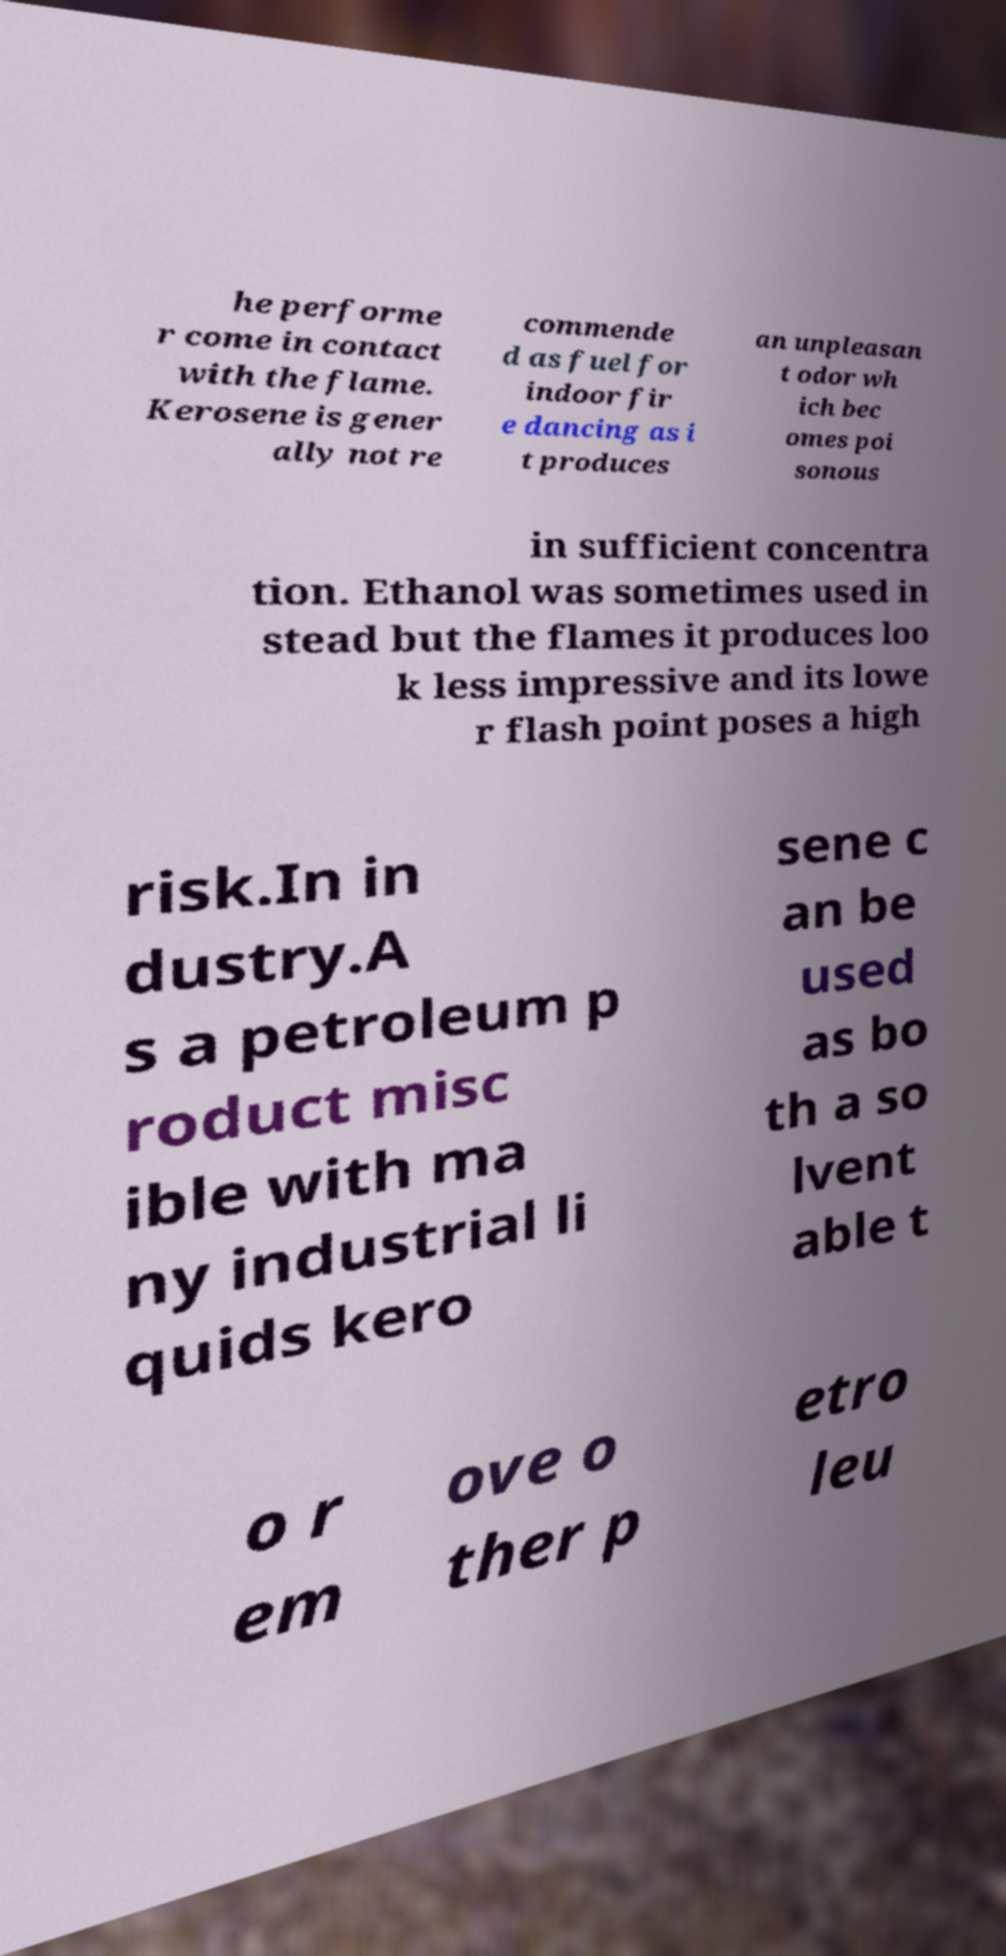Could you extract and type out the text from this image? he performe r come in contact with the flame. Kerosene is gener ally not re commende d as fuel for indoor fir e dancing as i t produces an unpleasan t odor wh ich bec omes poi sonous in sufficient concentra tion. Ethanol was sometimes used in stead but the flames it produces loo k less impressive and its lowe r flash point poses a high risk.In in dustry.A s a petroleum p roduct misc ible with ma ny industrial li quids kero sene c an be used as bo th a so lvent able t o r em ove o ther p etro leu 